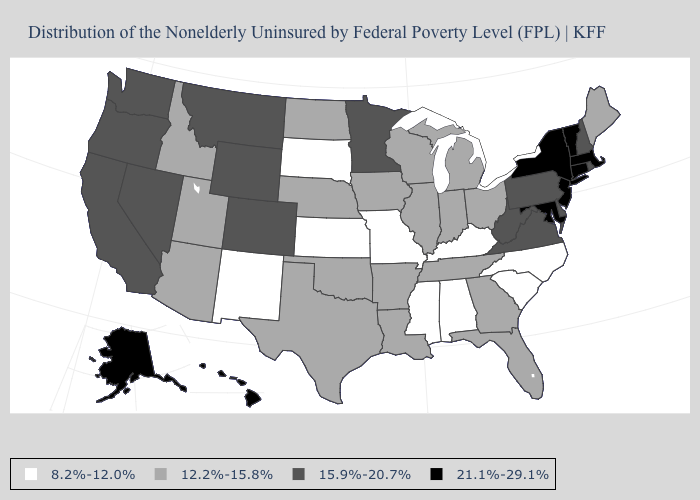What is the value of Maine?
Short answer required. 12.2%-15.8%. Among the states that border West Virginia , does Kentucky have the lowest value?
Quick response, please. Yes. What is the value of Nevada?
Give a very brief answer. 15.9%-20.7%. Does Alabama have the highest value in the USA?
Be succinct. No. Name the states that have a value in the range 12.2%-15.8%?
Concise answer only. Arizona, Arkansas, Florida, Georgia, Idaho, Illinois, Indiana, Iowa, Louisiana, Maine, Michigan, Nebraska, North Dakota, Ohio, Oklahoma, Tennessee, Texas, Utah, Wisconsin. What is the value of Hawaii?
Give a very brief answer. 21.1%-29.1%. Name the states that have a value in the range 8.2%-12.0%?
Short answer required. Alabama, Kansas, Kentucky, Mississippi, Missouri, New Mexico, North Carolina, South Carolina, South Dakota. Does Wisconsin have the same value as Michigan?
Short answer required. Yes. What is the value of Maine?
Quick response, please. 12.2%-15.8%. What is the lowest value in the West?
Short answer required. 8.2%-12.0%. Name the states that have a value in the range 12.2%-15.8%?
Answer briefly. Arizona, Arkansas, Florida, Georgia, Idaho, Illinois, Indiana, Iowa, Louisiana, Maine, Michigan, Nebraska, North Dakota, Ohio, Oklahoma, Tennessee, Texas, Utah, Wisconsin. Name the states that have a value in the range 8.2%-12.0%?
Give a very brief answer. Alabama, Kansas, Kentucky, Mississippi, Missouri, New Mexico, North Carolina, South Carolina, South Dakota. What is the highest value in the Northeast ?
Be succinct. 21.1%-29.1%. What is the value of Nevada?
Write a very short answer. 15.9%-20.7%. Does Mississippi have a lower value than South Carolina?
Quick response, please. No. 